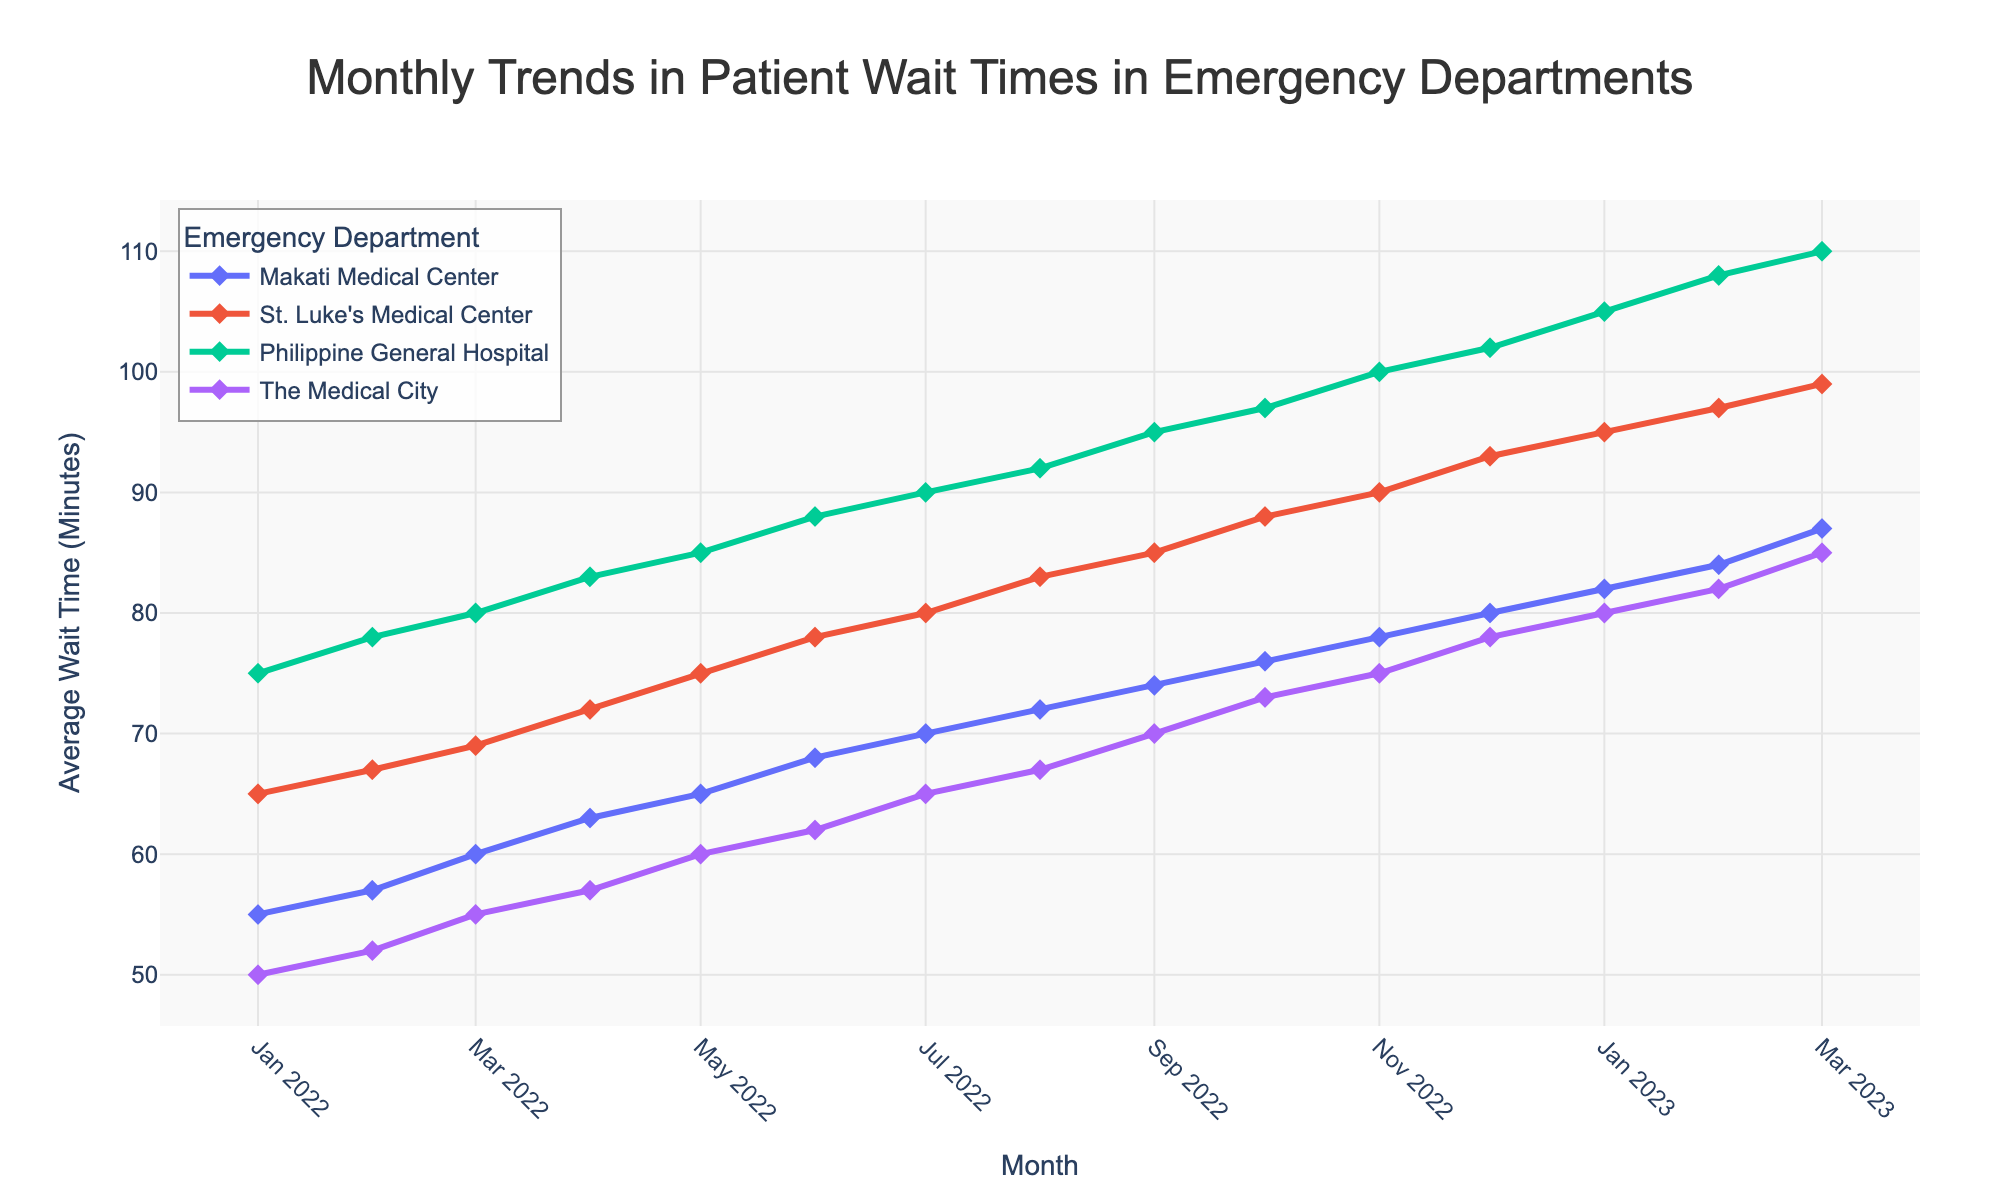What's the title of the figure? The title of the figure is usually displayed at the top of the plot. By looking at the plot, you can see the text that describes the main topic.
Answer: Monthly Trends in Patient Wait Times in Emergency Departments Which hospital had the highest average wait time in March 2023? To answer, locate March 2023 on the x-axis, then find the highest point for that month among the four traces. The highest y-value corresponds to the hospital with the highest wait time.
Answer: Philippine General Hospital How has the average wait time at Makati Medical Center changed from January 2022 to March 2023? Locate the data points for Makati Medical Center from January 2022 to March 2023 and connect them mentally or by following the line. Observe the trend and compare the initial and final values.
Answer: Increased from 55 to 87 minutes Which two hospitals had the closest average wait times in December 2022? Identify the data points for December 2022 and compare the y-values of each hospital. Look for the two lines that are the nearest to each other.
Answer: Philippine General Hospital and The Medical City What is the difference in wait times between St. Luke's Medical Center and The Medical City in February 2023? Find the y-values of St. Luke's Medical Center and The Medical City for February 2023 and subtract the two values to get the difference.
Answer: 15 minutes Which hospital showed the greatest increase in wait times from January 2022 to March 2023? Compare the difference in y-values for each hospital from January 2022 to March 2023. Identify the hospital with the largest positive change.
Answer: Philippine General Hospital What is the overall trend for patient wait times across all hospitals from January 2022 to March 2023? Observe the general direction of the lines representing each hospital. Note if they are increasing, decreasing, or staying constant.
Answer: Increasing By how much did the average wait time at St. Luke's Medical Center change from January 2022 to January 2023? Find the y-values of St. Luke's Medical Center for January 2022 and January 2023. Calculate the difference between these two values.
Answer: 30 minutes In which month did The Medical City have the smallest average wait time? Scan the plotted line for The Medical City and identify the lowest point on the y-axis. Note the corresponding month on the x-axis.
Answer: January 2022 